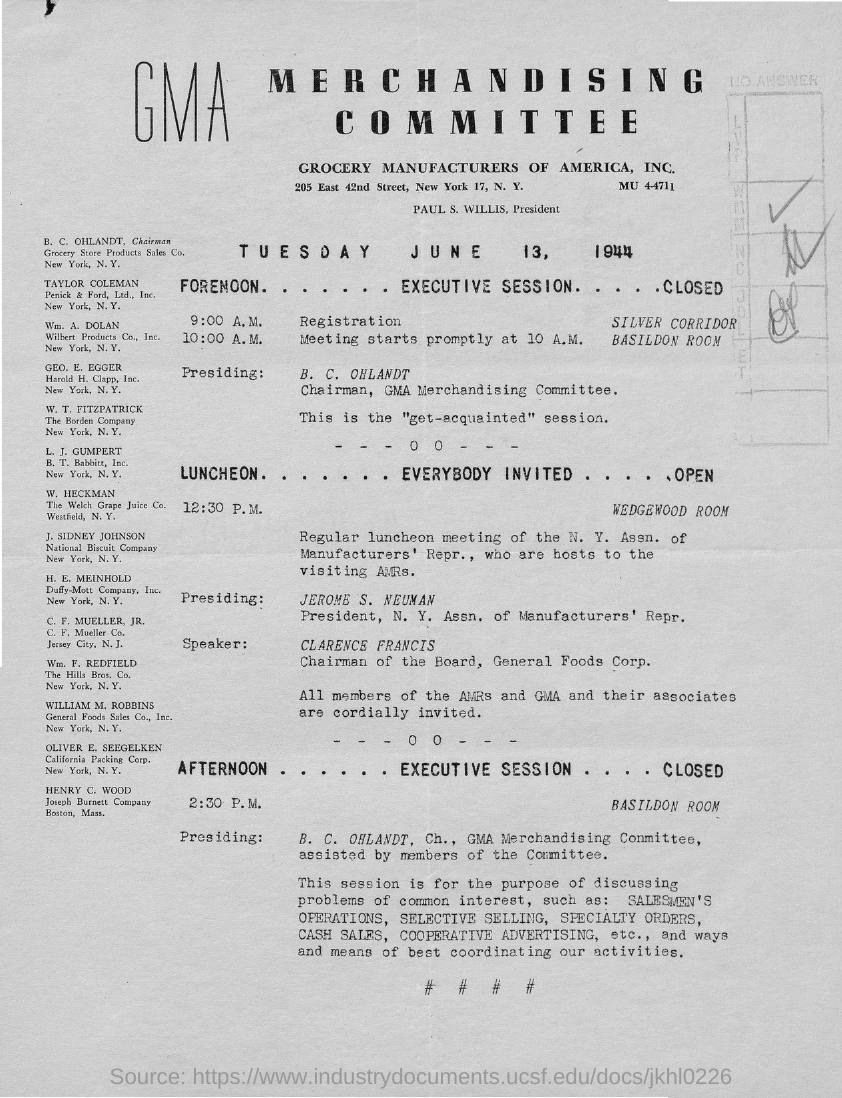Which "COMMITTEE" is mentioned in the heading?
Make the answer very short. MERCHANDISING COMMITTEE. What is the "registration" time for the " FORENOON"  Session?
Offer a very short reply. 9:00 A.M. When will the "meeting start"?
Provide a short and direct response. 10:00 A.M. Who is "Presiding" the "FORENOON" executive session?
Your answer should be very brief. B.C OHLANDT. Who is the "Speaker"?
Give a very brief answer. CLARENCE FRANCIS. What is the designation of "CLARENCE FRANCIS"?
Give a very brief answer. CHAIRMAN OF THE BOARD. "AFTERNOON"  session starts at what time?
Provide a succinct answer. 2:30 P.M. Where is "Grocery Store Products Sales Co" located?
Ensure brevity in your answer.  NEW YORK. 